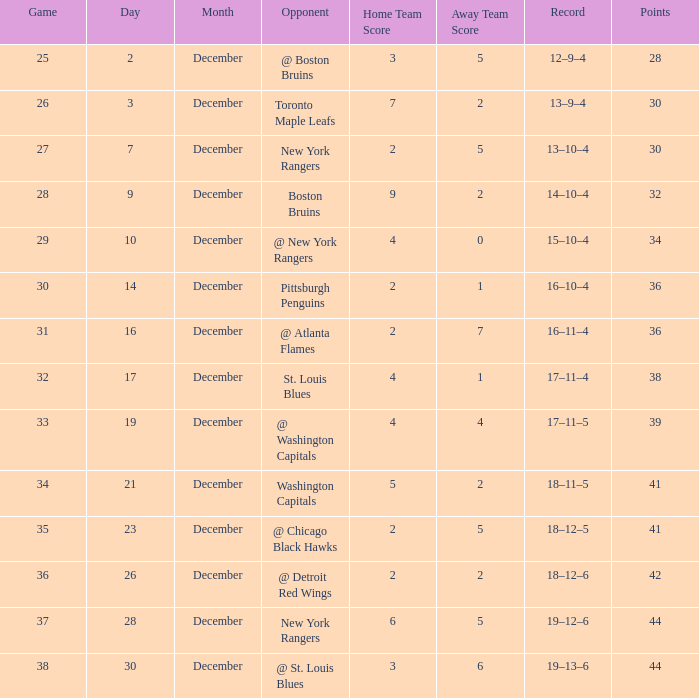What score consists of 36 points and a 30-game? 2–1. 